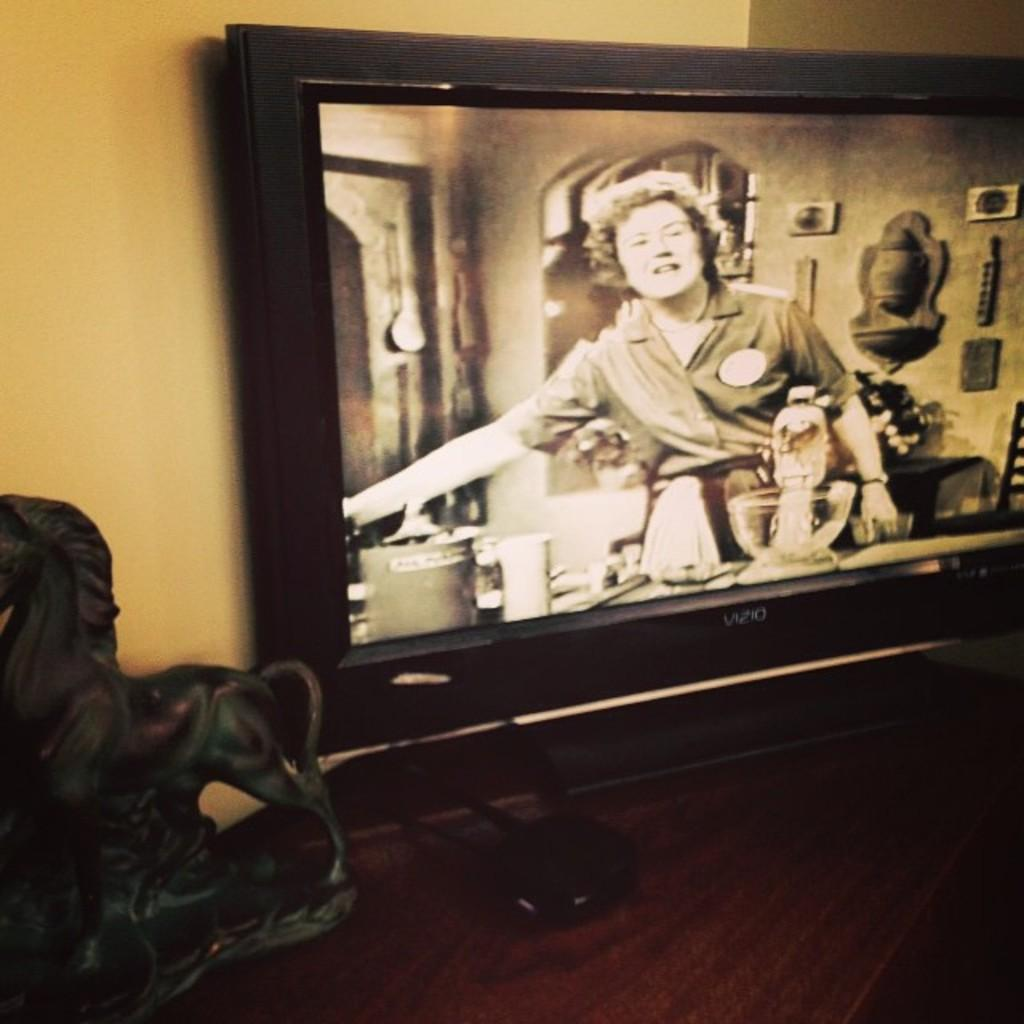What electronic device is present in the image? There is a television in the image. Where is the television located? The television is placed on a wooden shelf. Can you describe the person in the image? There is a woman standing in the image. What is the slope of the number displayed on the television in the image? There is no number displayed on the television in the image, so it is not possible to determine the slope. 